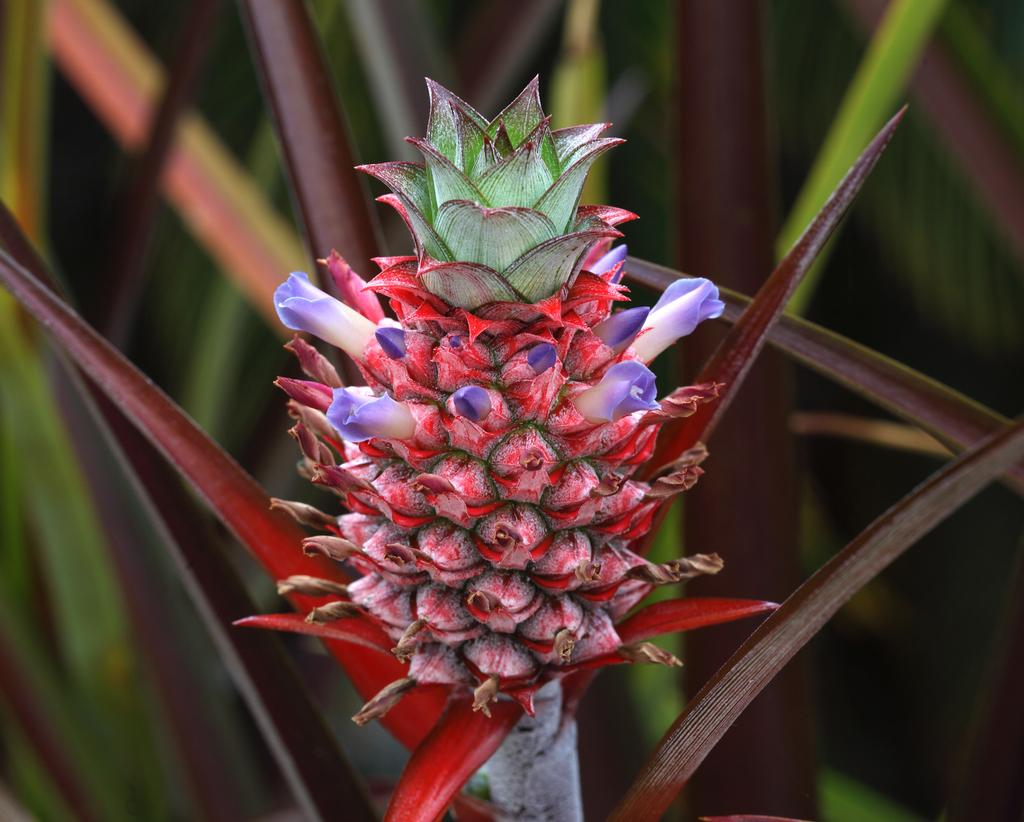What is the main subject of the image? There is a bunch of flowers in the image. Are there any other plant-related elements in the image? Yes, there are leaves in the image. Reasoning: Leting: Let's think step by step in order to produce the conversation. We start by identifying the main subject of the image, which is the bunch of flowers. Then, we expand the conversation to include other plant-related elements that are also visible, such as leaves. Each question is designed to elicit a specific detail about the image that is known from the provided facts. Absurd Question/Answer: What type of crack can be seen in the image? There is no crack present in the image. What color is the bead hanging from the flowers in the image? There is no bead present in the image. What type of cord is used to hold the flowers together in the image? There is no cord present in the image; the flowers are not held together by any visible means. 